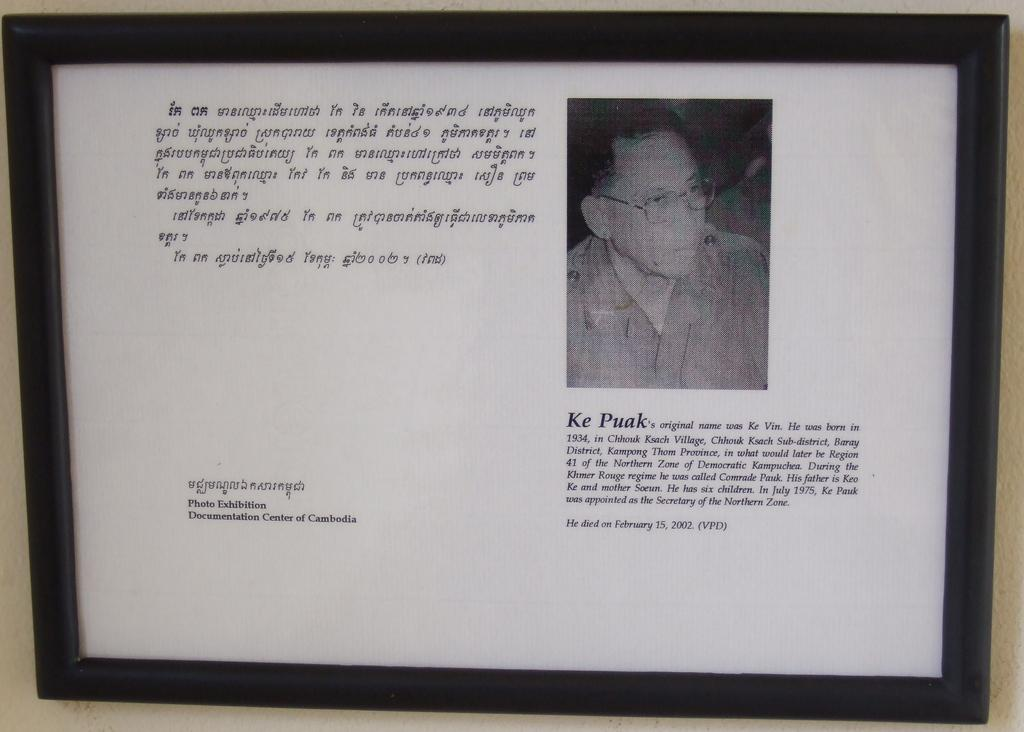<image>
Write a terse but informative summary of the picture. the name Puak is on the white sign 